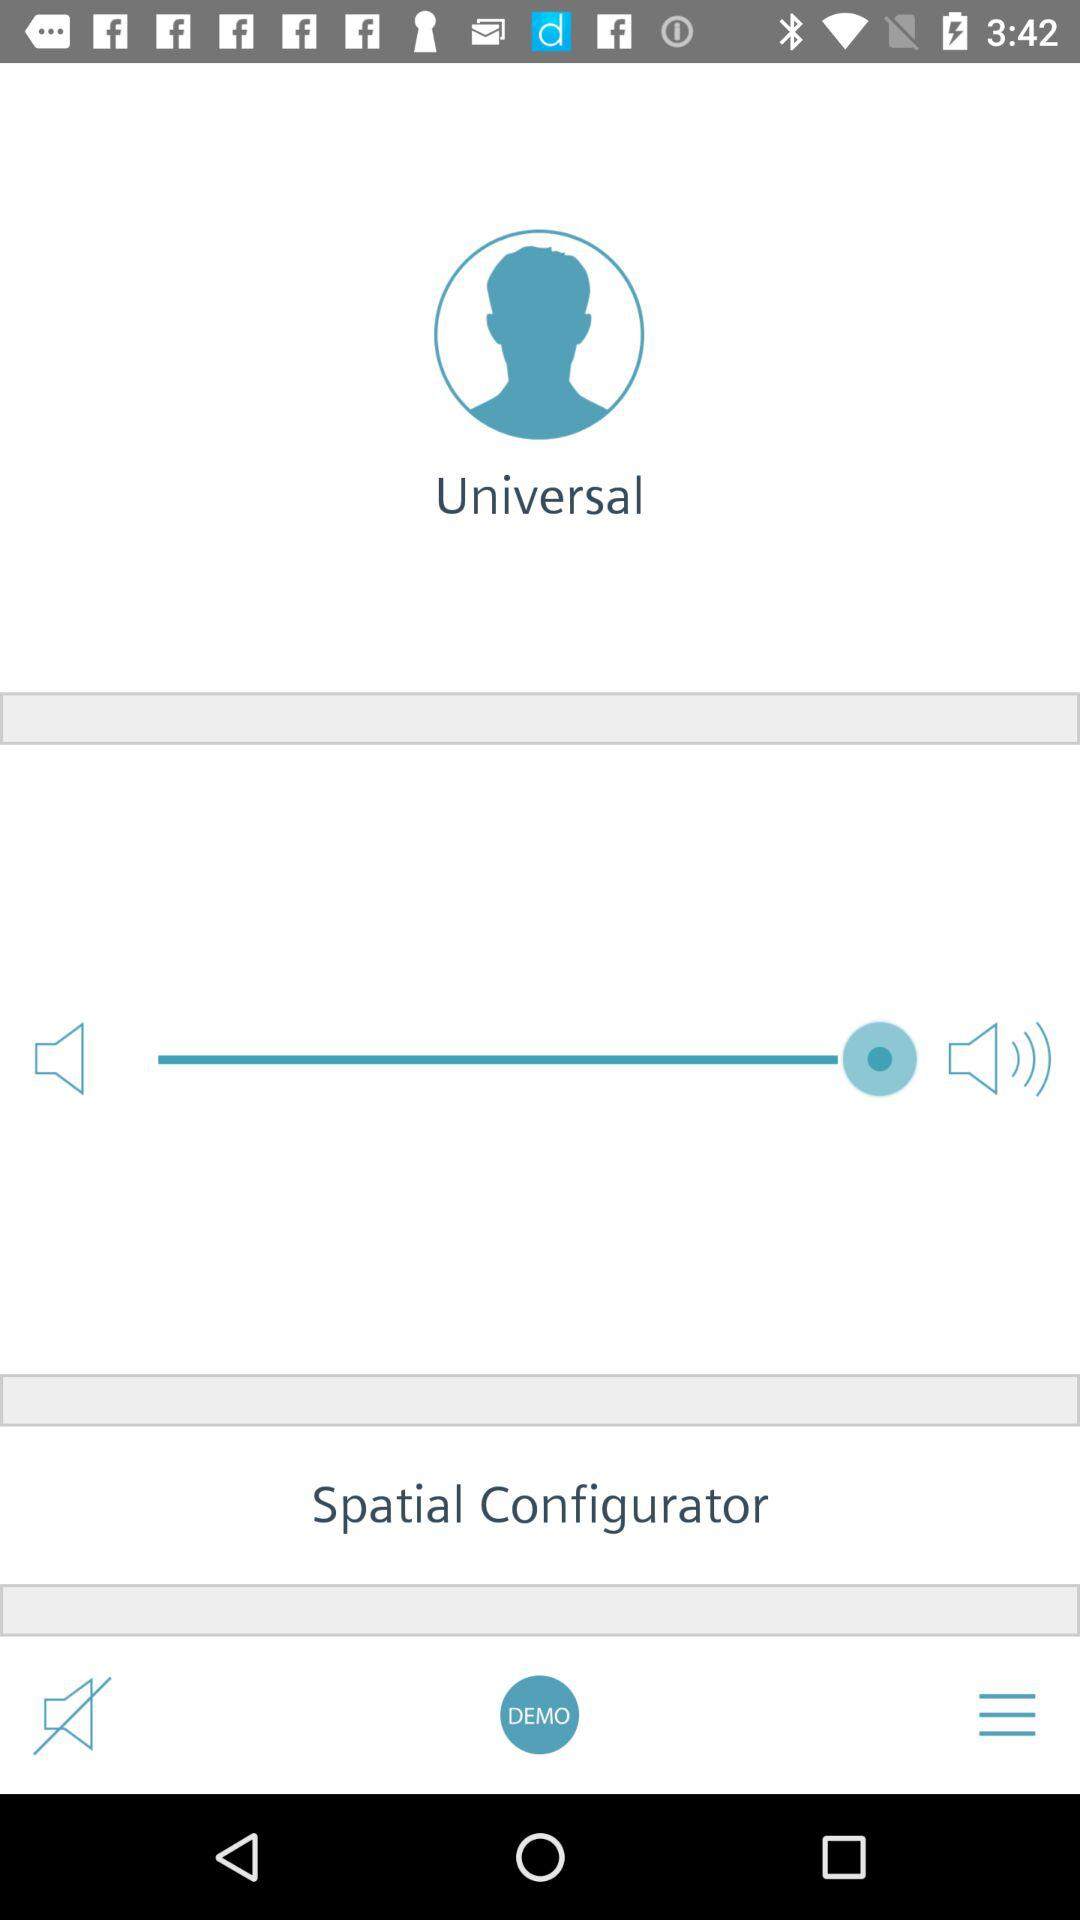What is the user name? The user name is Universal. 